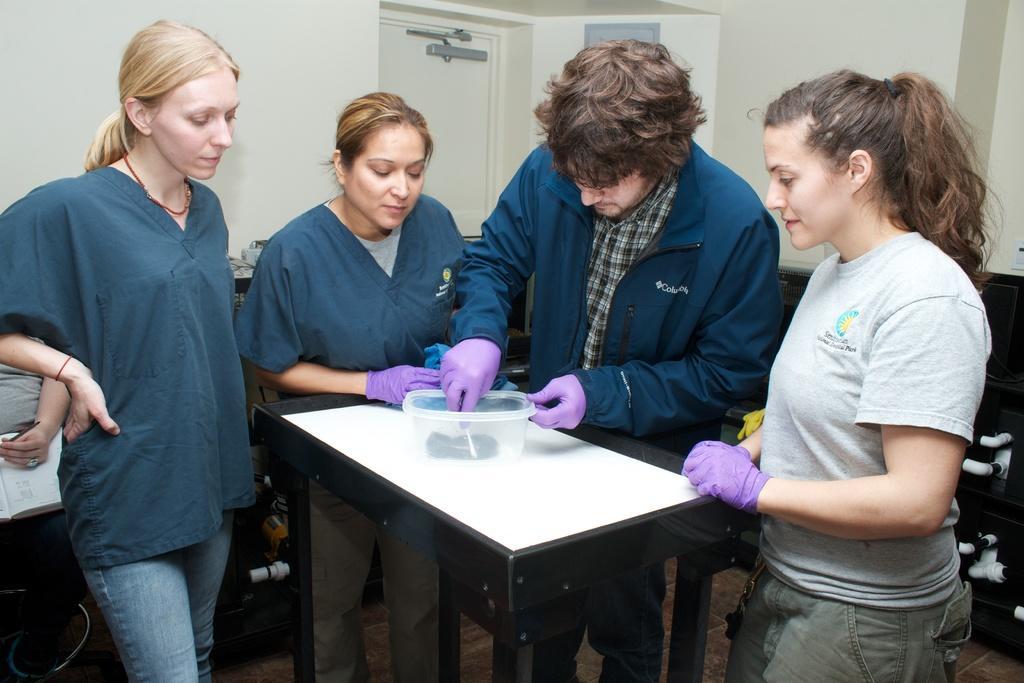In one or two sentences, can you explain what this image depicts? In the picture we can find four persons standing, There are girls and one is man they are standing near the table. In the background we can find a door and the wall. And on the table we can find some box. The persons are checking something in that box. They are wearing a violet gloves. 